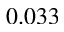<formula> <loc_0><loc_0><loc_500><loc_500>0 . 0 3 3</formula> 